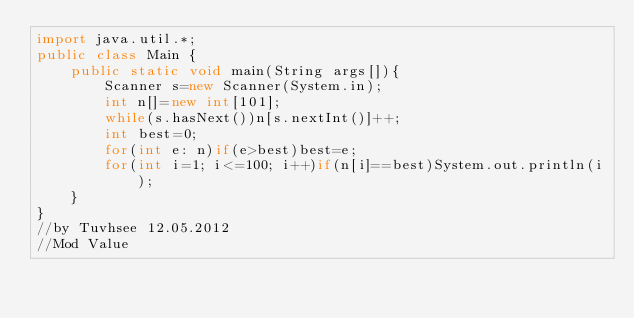Convert code to text. <code><loc_0><loc_0><loc_500><loc_500><_Java_>import java.util.*;
public class Main {
    public static void main(String args[]){
        Scanner s=new Scanner(System.in);
        int n[]=new int[101];
        while(s.hasNext())n[s.nextInt()]++;
        int best=0;
        for(int e: n)if(e>best)best=e;
        for(int i=1; i<=100; i++)if(n[i]==best)System.out.println(i);
    }
}
//by Tuvhsee 12.05.2012
//Mod Value</code> 